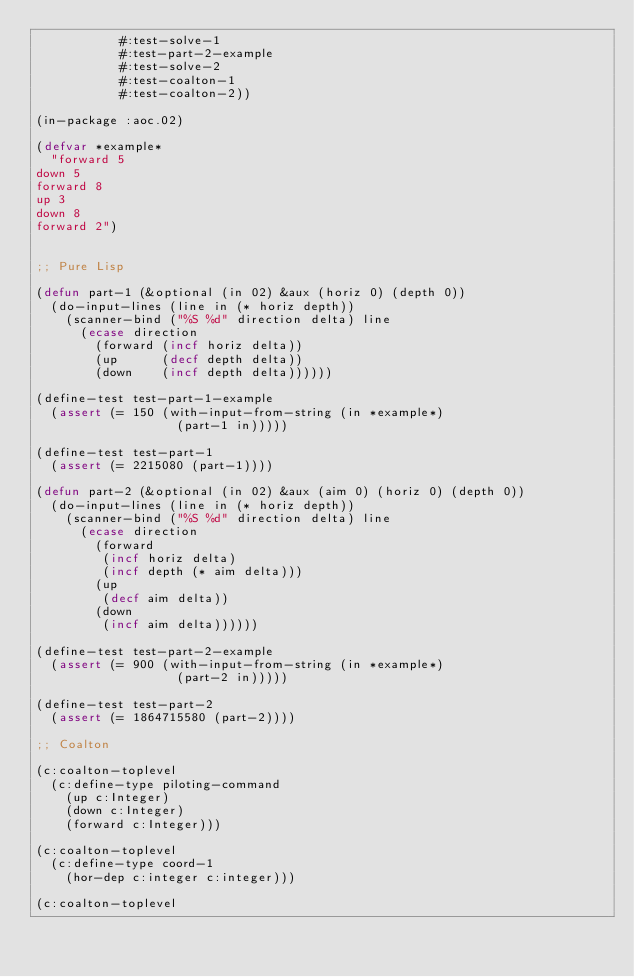Convert code to text. <code><loc_0><loc_0><loc_500><loc_500><_Lisp_>           #:test-solve-1
           #:test-part-2-example
           #:test-solve-2
           #:test-coalton-1
           #:test-coalton-2))

(in-package :aoc.02)

(defvar *example*
  "forward 5
down 5
forward 8
up 3
down 8
forward 2")


;; Pure Lisp

(defun part-1 (&optional (in 02) &aux (horiz 0) (depth 0))
  (do-input-lines (line in (* horiz depth))
    (scanner-bind ("%S %d" direction delta) line
      (ecase direction
        (forward (incf horiz delta))
        (up      (decf depth delta))
        (down    (incf depth delta))))))

(define-test test-part-1-example
  (assert (= 150 (with-input-from-string (in *example*)
                   (part-1 in)))))

(define-test test-part-1
  (assert (= 2215080 (part-1))))

(defun part-2 (&optional (in 02) &aux (aim 0) (horiz 0) (depth 0))
  (do-input-lines (line in (* horiz depth))
    (scanner-bind ("%S %d" direction delta) line
      (ecase direction
        (forward 
         (incf horiz delta)
         (incf depth (* aim delta)))
        (up
         (decf aim delta))
        (down
         (incf aim delta))))))

(define-test test-part-2-example
  (assert (= 900 (with-input-from-string (in *example*)
                   (part-2 in)))))

(define-test test-part-2
  (assert (= 1864715580 (part-2))))

;; Coalton

(c:coalton-toplevel
  (c:define-type piloting-command
    (up c:Integer)
    (down c:Integer)
    (forward c:Integer)))

(c:coalton-toplevel
  (c:define-type coord-1
    (hor-dep c:integer c:integer)))

(c:coalton-toplevel</code> 